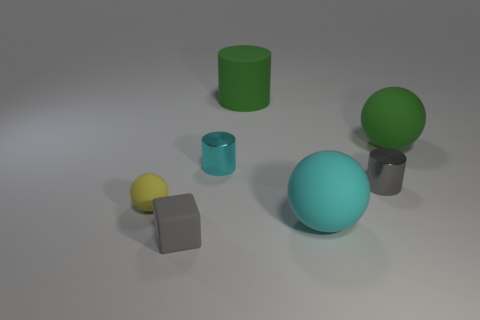Add 1 big cyan rubber balls. How many objects exist? 8 Subtract all blocks. How many objects are left? 6 Subtract 0 blue cubes. How many objects are left? 7 Subtract all cyan cylinders. Subtract all large rubber cylinders. How many objects are left? 5 Add 2 tiny yellow matte objects. How many tiny yellow matte objects are left? 3 Add 7 green rubber objects. How many green rubber objects exist? 9 